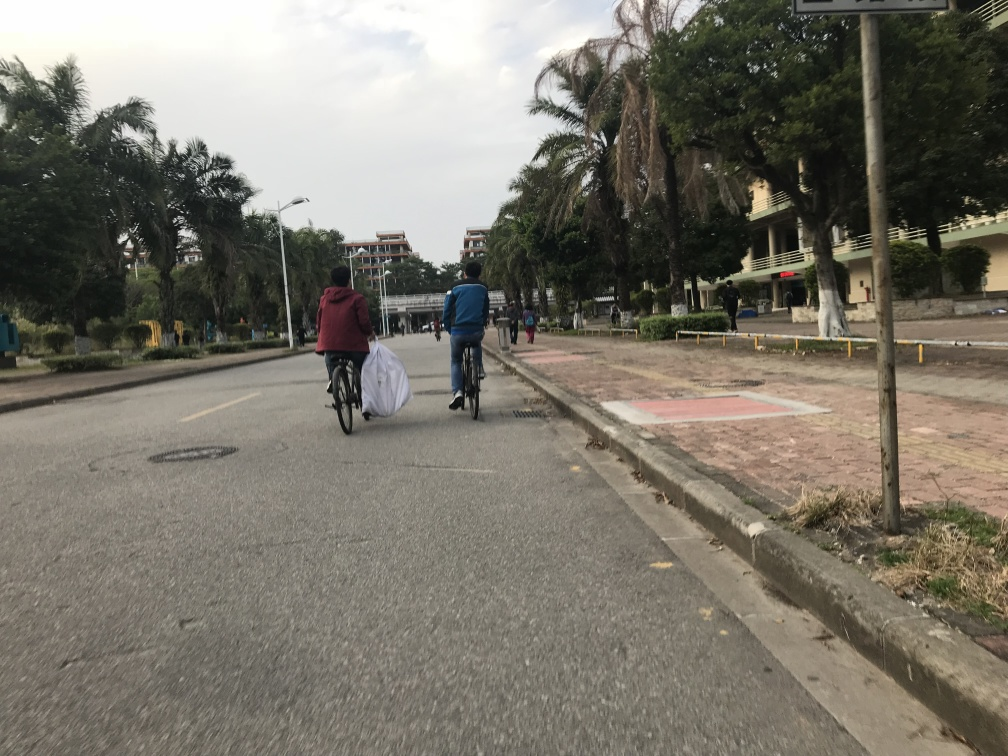Is there any motion blur in capturing the person riding a bike? Upon reviewing the image, I can confirm there is no noticeable motion blur affecting the visibility of the person riding the bike. The defined edges and clear view of the individual and the bicycle spokes suggest a quick shutter speed was used, preserving the details without blur. 